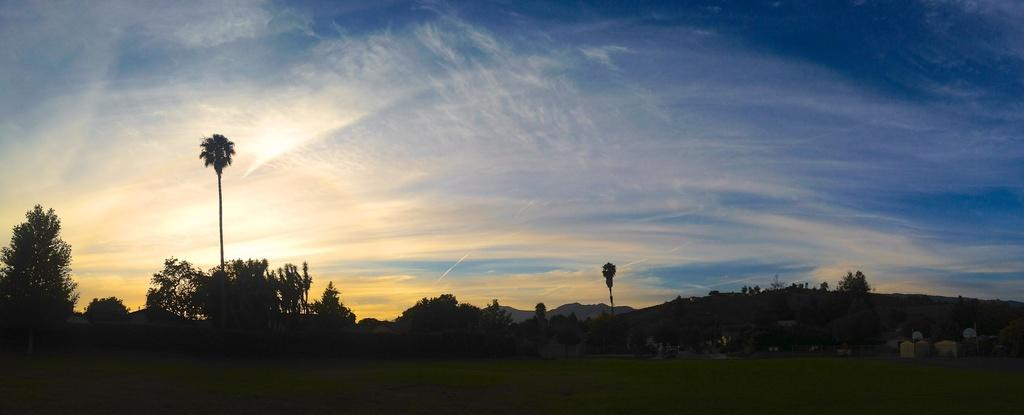What type of vegetation is at the bottom of the image? There is grass at the bottom of the image. What can be seen in the background of the image? There are trees, mountains, buildings, and the sky visible in the background of the image. What type of engine can be seen powering the stream in the image? There is no engine or stream present in the image. 